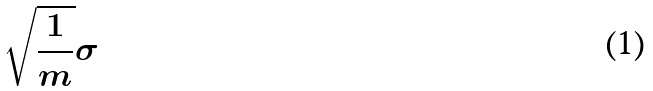<formula> <loc_0><loc_0><loc_500><loc_500>\sqrt { \frac { 1 } { m } } \sigma</formula> 